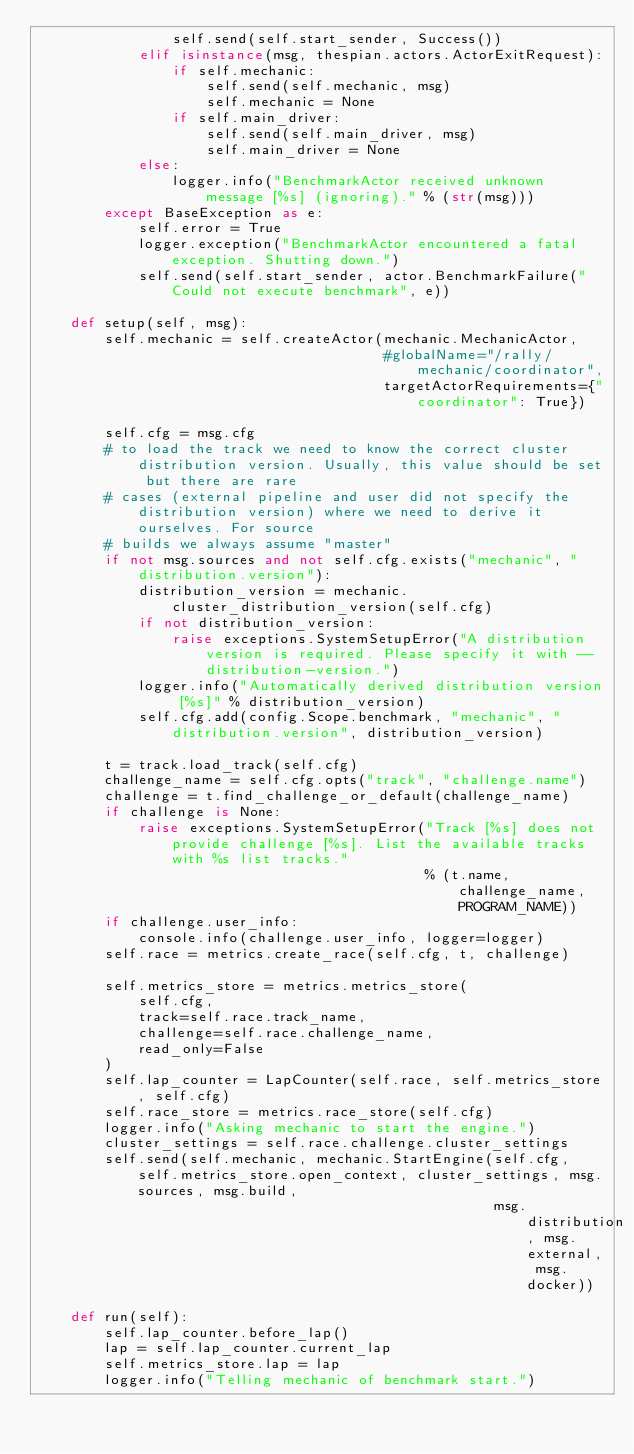Convert code to text. <code><loc_0><loc_0><loc_500><loc_500><_Python_>                self.send(self.start_sender, Success())
            elif isinstance(msg, thespian.actors.ActorExitRequest):
                if self.mechanic:
                    self.send(self.mechanic, msg)
                    self.mechanic = None
                if self.main_driver:
                    self.send(self.main_driver, msg)
                    self.main_driver = None
            else:
                logger.info("BenchmarkActor received unknown message [%s] (ignoring)." % (str(msg)))
        except BaseException as e:
            self.error = True
            logger.exception("BenchmarkActor encountered a fatal exception. Shutting down.")
            self.send(self.start_sender, actor.BenchmarkFailure("Could not execute benchmark", e))

    def setup(self, msg):
        self.mechanic = self.createActor(mechanic.MechanicActor,
                                         #globalName="/rally/mechanic/coordinator",
                                         targetActorRequirements={"coordinator": True})

        self.cfg = msg.cfg
        # to load the track we need to know the correct cluster distribution version. Usually, this value should be set but there are rare
        # cases (external pipeline and user did not specify the distribution version) where we need to derive it ourselves. For source
        # builds we always assume "master"
        if not msg.sources and not self.cfg.exists("mechanic", "distribution.version"):
            distribution_version = mechanic.cluster_distribution_version(self.cfg)
            if not distribution_version:
                raise exceptions.SystemSetupError("A distribution version is required. Please specify it with --distribution-version.")
            logger.info("Automatically derived distribution version [%s]" % distribution_version)
            self.cfg.add(config.Scope.benchmark, "mechanic", "distribution.version", distribution_version)

        t = track.load_track(self.cfg)
        challenge_name = self.cfg.opts("track", "challenge.name")
        challenge = t.find_challenge_or_default(challenge_name)
        if challenge is None:
            raise exceptions.SystemSetupError("Track [%s] does not provide challenge [%s]. List the available tracks with %s list tracks."
                                              % (t.name, challenge_name, PROGRAM_NAME))
        if challenge.user_info:
            console.info(challenge.user_info, logger=logger)
        self.race = metrics.create_race(self.cfg, t, challenge)

        self.metrics_store = metrics.metrics_store(
            self.cfg,
            track=self.race.track_name,
            challenge=self.race.challenge_name,
            read_only=False
        )
        self.lap_counter = LapCounter(self.race, self.metrics_store, self.cfg)
        self.race_store = metrics.race_store(self.cfg)
        logger.info("Asking mechanic to start the engine.")
        cluster_settings = self.race.challenge.cluster_settings
        self.send(self.mechanic, mechanic.StartEngine(self.cfg, self.metrics_store.open_context, cluster_settings, msg.sources, msg.build,
                                                      msg.distribution, msg.external, msg.docker))

    def run(self):
        self.lap_counter.before_lap()
        lap = self.lap_counter.current_lap
        self.metrics_store.lap = lap
        logger.info("Telling mechanic of benchmark start.")</code> 